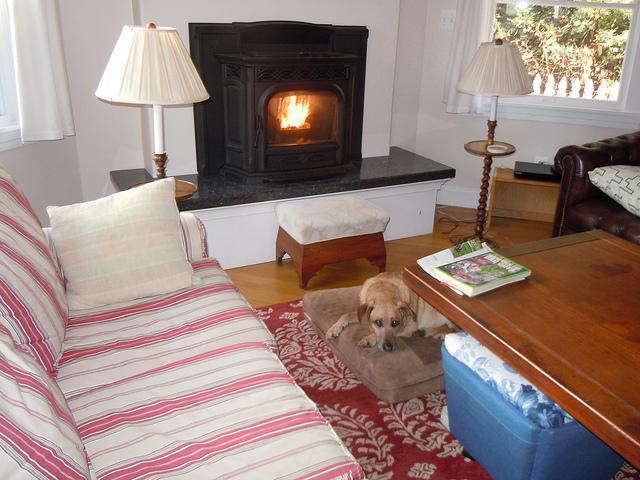What is the dog lying on?
Indicate the correct response by choosing from the four available options to answer the question.
Options: Couch cushion, head rest, blanket, dog bed. Dog bed. 